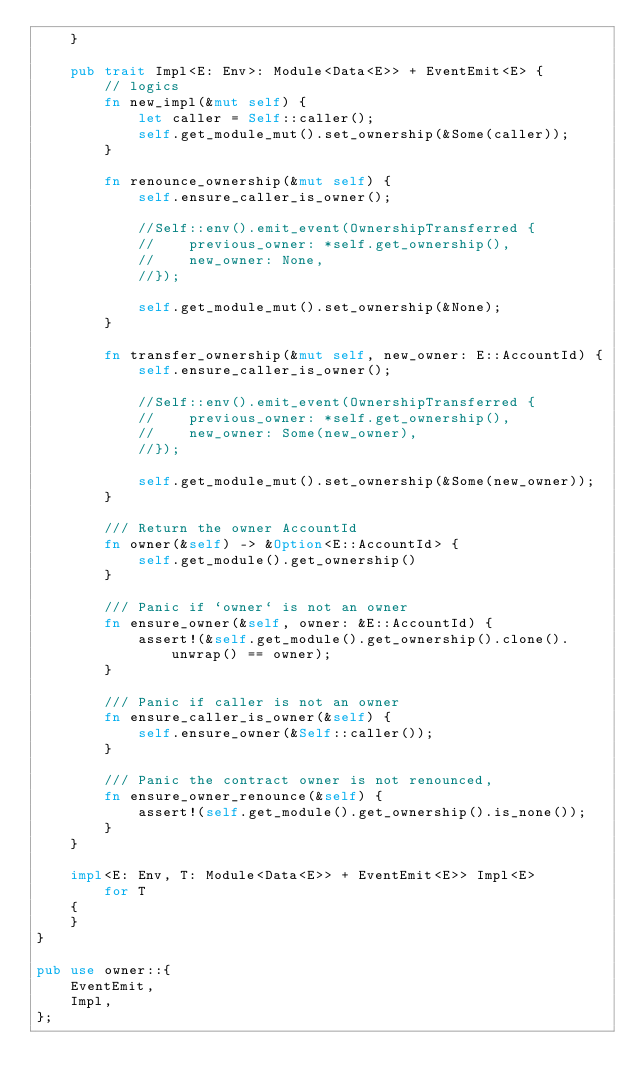Convert code to text. <code><loc_0><loc_0><loc_500><loc_500><_Rust_>    }

    pub trait Impl<E: Env>: Module<Data<E>> + EventEmit<E> {
        // logics
        fn new_impl(&mut self) {
            let caller = Self::caller();
            self.get_module_mut().set_ownership(&Some(caller));
        }

        fn renounce_ownership(&mut self) {
            self.ensure_caller_is_owner();

            //Self::env().emit_event(OwnershipTransferred {
            //    previous_owner: *self.get_ownership(),
            //    new_owner: None,
            //});

            self.get_module_mut().set_ownership(&None);
        }

        fn transfer_ownership(&mut self, new_owner: E::AccountId) {
            self.ensure_caller_is_owner();

            //Self::env().emit_event(OwnershipTransferred {
            //    previous_owner: *self.get_ownership(),
            //    new_owner: Some(new_owner),
            //});

            self.get_module_mut().set_ownership(&Some(new_owner));
        }

        /// Return the owner AccountId
        fn owner(&self) -> &Option<E::AccountId> {
            self.get_module().get_ownership()
        }

        /// Panic if `owner` is not an owner
        fn ensure_owner(&self, owner: &E::AccountId) {
            assert!(&self.get_module().get_ownership().clone().unwrap() == owner);
        }

        /// Panic if caller is not an owner
        fn ensure_caller_is_owner(&self) {
            self.ensure_owner(&Self::caller());
        }

        /// Panic the contract owner is not renounced,
        fn ensure_owner_renounce(&self) {
            assert!(self.get_module().get_ownership().is_none());
        }
    }

    impl<E: Env, T: Module<Data<E>> + EventEmit<E>> Impl<E>
        for T
    {
    }
}

pub use owner::{
    EventEmit,
    Impl,
};
</code> 